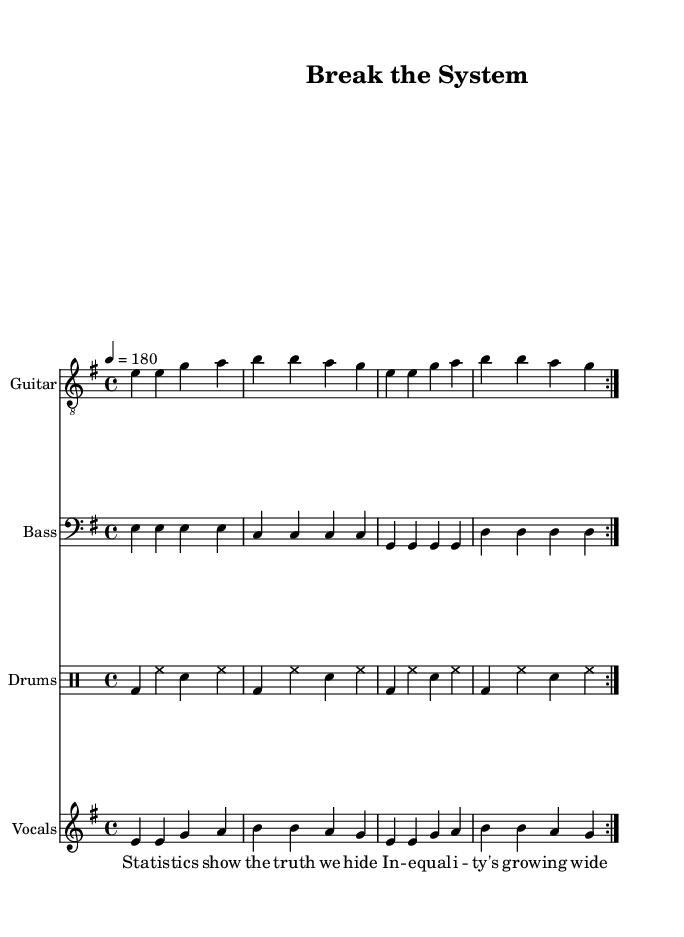what is the key signature of this music? The key signature is E minor, which has one sharp (F#) as indicated at the beginning of the sheet music.
Answer: E minor what is the time signature of this music? The time signature shown in the music is 4/4, which indicates there are four beats per measure.
Answer: 4/4 what is the tempo of this music? The tempo marking is indicated at the start of the score as 4 = 180, which means there are 180 beats per minute.
Answer: 180 how many measures are repeated in the guitar music? The guitar music includes a repeat sign, and there are two measures that are repeated as indicated by the "volta."
Answer: 2 measures what is the title of this piece? The title is located in the header section at the top of the sheet music. It states "Break the System."
Answer: Break the System why is the song considered an anti-establishment anthem? The lyrics address themes of systemic oppression and economic justice, calling for the breaking down of established systems. This reflection on social issues is a hallmark of punk music's anti-establishment stance.
Answer: Themes of systemic oppression how are the lyrics structured in this song? The lyrics are typically divided into verses and a chorus, with each section having distinct yet repetitive phrases that emphasize the overall message. This structure is common in punk music to drive home themes of rebellion.
Answer: Verses and chorus 